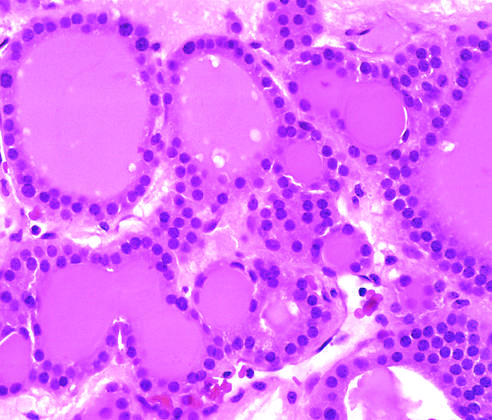s borderline serous cystadenoma visible in this gross specimen?
Answer the question using a single word or phrase. No 